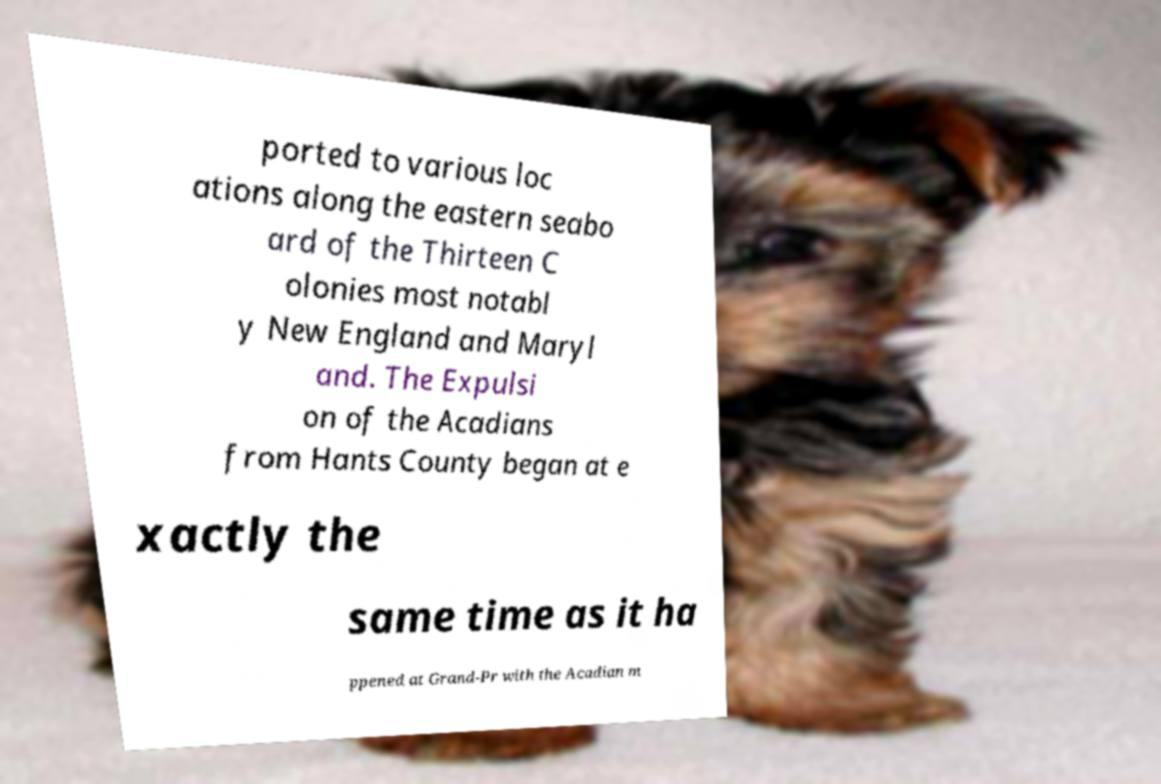For documentation purposes, I need the text within this image transcribed. Could you provide that? ported to various loc ations along the eastern seabo ard of the Thirteen C olonies most notabl y New England and Maryl and. The Expulsi on of the Acadians from Hants County began at e xactly the same time as it ha ppened at Grand-Pr with the Acadian m 